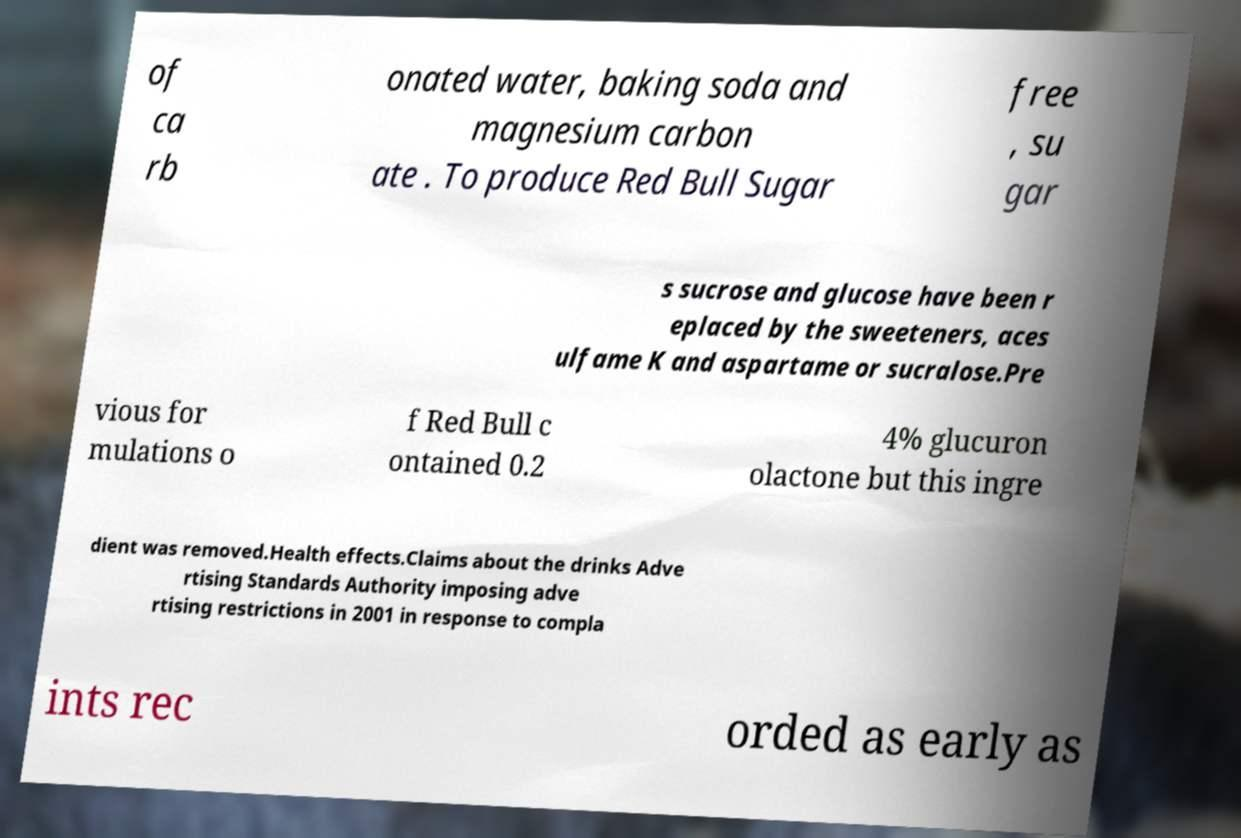Please read and relay the text visible in this image. What does it say? of ca rb onated water, baking soda and magnesium carbon ate . To produce Red Bull Sugar free , su gar s sucrose and glucose have been r eplaced by the sweeteners, aces ulfame K and aspartame or sucralose.Pre vious for mulations o f Red Bull c ontained 0.2 4% glucuron olactone but this ingre dient was removed.Health effects.Claims about the drinks Adve rtising Standards Authority imposing adve rtising restrictions in 2001 in response to compla ints rec orded as early as 